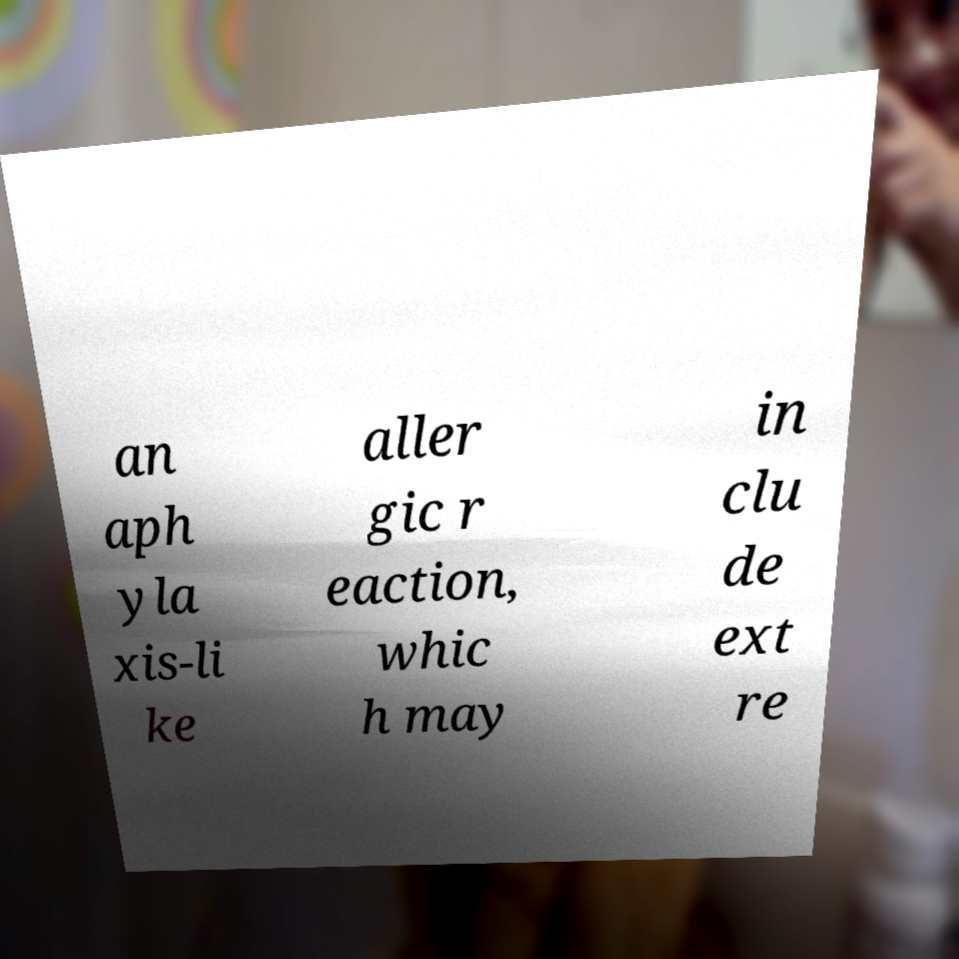What messages or text are displayed in this image? I need them in a readable, typed format. an aph yla xis-li ke aller gic r eaction, whic h may in clu de ext re 